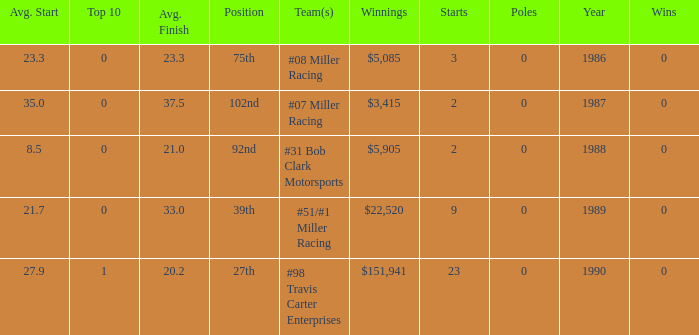What are the racing teams for which the average finish is 23.3? #08 Miller Racing. 